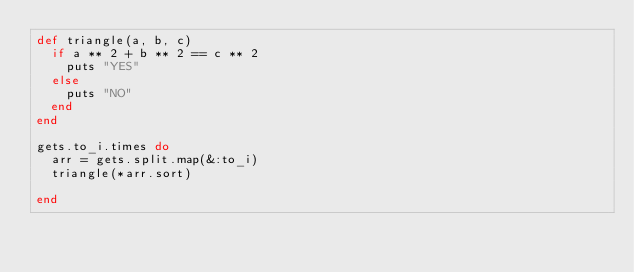<code> <loc_0><loc_0><loc_500><loc_500><_Ruby_>def triangle(a, b, c)
  if a ** 2 + b ** 2 == c ** 2
    puts "YES"
  else
    puts "NO"
  end
end

gets.to_i.times do
  arr = gets.split.map(&:to_i)
  triangle(*arr.sort)
  
end</code> 